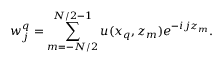<formula> <loc_0><loc_0><loc_500><loc_500>w _ { j } ^ { q } = \sum _ { m = - N / 2 } ^ { N / 2 - 1 } u ( x _ { q } , z _ { m } ) e ^ { - i j z _ { m } } .</formula> 